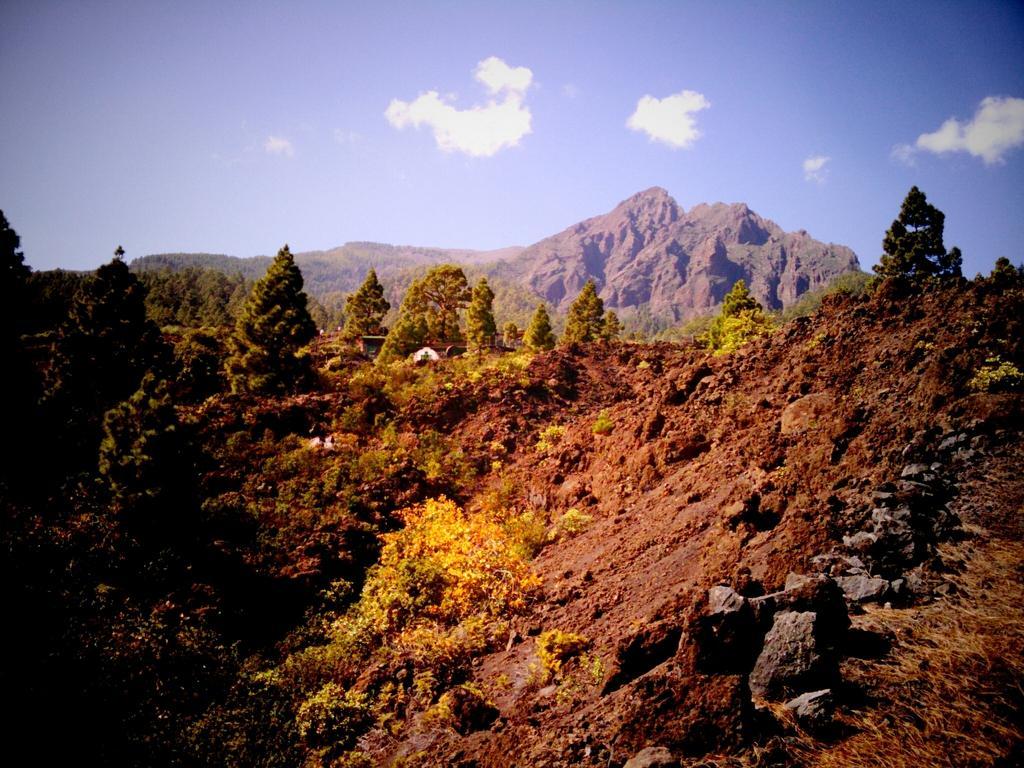How would you summarize this image in a sentence or two? Here we can see trees,grass and stone on the ground. In the background there are mountains and clouds in the sky. 